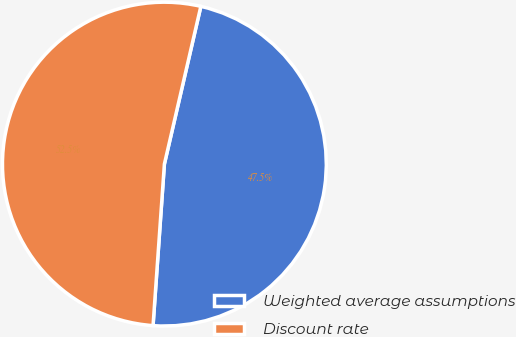Convert chart. <chart><loc_0><loc_0><loc_500><loc_500><pie_chart><fcel>Weighted average assumptions<fcel>Discount rate<nl><fcel>47.5%<fcel>52.5%<nl></chart> 